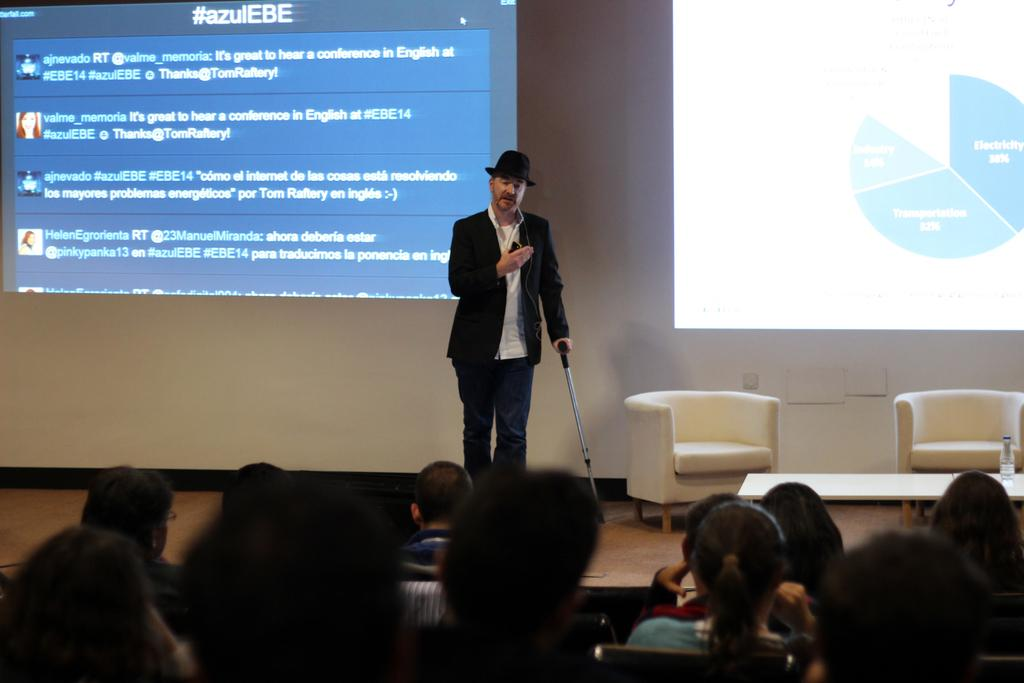Who is the main subject in the image? There is a man in the image. What is the man doing in the image? The man is speaking to an audience. How is the audience positioned in relation to the man? The audience is seated in front of the man. What can be seen on the wall in the image? There is a projection light on the wall. How many chairs are visible in the image? There are two chairs in the image. Is there any furniture other than chairs in the image? Yes, there is a table in the image. How many lizards can be seen crawling on the table in the image? There are no lizards present in the image; the table is empty. 